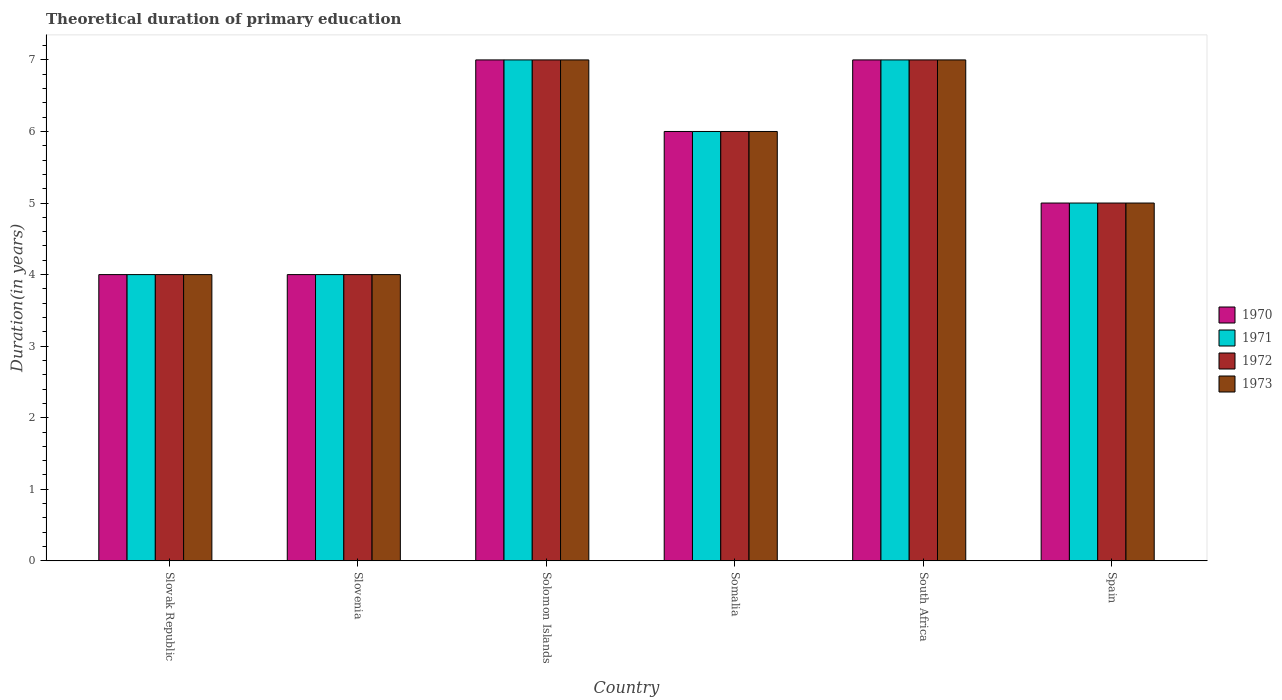Are the number of bars per tick equal to the number of legend labels?
Keep it short and to the point. Yes. Are the number of bars on each tick of the X-axis equal?
Provide a short and direct response. Yes. How many bars are there on the 2nd tick from the right?
Provide a succinct answer. 4. What is the label of the 6th group of bars from the left?
Offer a terse response. Spain. In how many cases, is the number of bars for a given country not equal to the number of legend labels?
Your answer should be very brief. 0. What is the total theoretical duration of primary education in 1971 in Slovenia?
Your answer should be compact. 4. Across all countries, what is the minimum total theoretical duration of primary education in 1973?
Make the answer very short. 4. In which country was the total theoretical duration of primary education in 1972 maximum?
Provide a succinct answer. Solomon Islands. In which country was the total theoretical duration of primary education in 1972 minimum?
Your answer should be very brief. Slovak Republic. What is the difference between the total theoretical duration of primary education in 1971 in Spain and the total theoretical duration of primary education in 1973 in Solomon Islands?
Ensure brevity in your answer.  -2. In how many countries, is the total theoretical duration of primary education in 1971 greater than 5.4 years?
Offer a terse response. 3. What is the ratio of the total theoretical duration of primary education in 1972 in Slovak Republic to that in South Africa?
Your response must be concise. 0.57. Is the total theoretical duration of primary education in 1972 in Somalia less than that in Spain?
Provide a short and direct response. No. What is the difference between the highest and the second highest total theoretical duration of primary education in 1973?
Provide a succinct answer. -1. What is the difference between the highest and the lowest total theoretical duration of primary education in 1971?
Offer a terse response. 3. Is the sum of the total theoretical duration of primary education in 1971 in Slovenia and Spain greater than the maximum total theoretical duration of primary education in 1973 across all countries?
Offer a terse response. Yes. What does the 2nd bar from the right in Slovenia represents?
Keep it short and to the point. 1972. How many bars are there?
Your response must be concise. 24. Are all the bars in the graph horizontal?
Provide a short and direct response. No. Are the values on the major ticks of Y-axis written in scientific E-notation?
Ensure brevity in your answer.  No. Does the graph contain any zero values?
Make the answer very short. No. Where does the legend appear in the graph?
Your response must be concise. Center right. How many legend labels are there?
Provide a succinct answer. 4. What is the title of the graph?
Keep it short and to the point. Theoretical duration of primary education. What is the label or title of the X-axis?
Your response must be concise. Country. What is the label or title of the Y-axis?
Keep it short and to the point. Duration(in years). What is the Duration(in years) in 1971 in Slovak Republic?
Make the answer very short. 4. What is the Duration(in years) of 1972 in Slovak Republic?
Make the answer very short. 4. What is the Duration(in years) of 1970 in Slovenia?
Offer a terse response. 4. What is the Duration(in years) of 1971 in Slovenia?
Provide a short and direct response. 4. What is the Duration(in years) in 1972 in Solomon Islands?
Your answer should be very brief. 7. What is the Duration(in years) in 1973 in Solomon Islands?
Give a very brief answer. 7. What is the Duration(in years) in 1971 in Somalia?
Provide a succinct answer. 6. What is the Duration(in years) of 1973 in Somalia?
Ensure brevity in your answer.  6. What is the Duration(in years) in 1971 in South Africa?
Give a very brief answer. 7. What is the Duration(in years) of 1972 in South Africa?
Offer a terse response. 7. What is the Duration(in years) of 1970 in Spain?
Ensure brevity in your answer.  5. What is the Duration(in years) of 1971 in Spain?
Ensure brevity in your answer.  5. Across all countries, what is the minimum Duration(in years) of 1970?
Offer a terse response. 4. Across all countries, what is the minimum Duration(in years) in 1971?
Give a very brief answer. 4. Across all countries, what is the minimum Duration(in years) of 1972?
Your answer should be compact. 4. Across all countries, what is the minimum Duration(in years) of 1973?
Your answer should be compact. 4. What is the total Duration(in years) in 1971 in the graph?
Provide a succinct answer. 33. What is the total Duration(in years) of 1972 in the graph?
Make the answer very short. 33. What is the total Duration(in years) of 1973 in the graph?
Give a very brief answer. 33. What is the difference between the Duration(in years) in 1970 in Slovak Republic and that in Slovenia?
Provide a short and direct response. 0. What is the difference between the Duration(in years) of 1971 in Slovak Republic and that in Slovenia?
Provide a succinct answer. 0. What is the difference between the Duration(in years) of 1973 in Slovak Republic and that in Slovenia?
Offer a very short reply. 0. What is the difference between the Duration(in years) of 1971 in Slovak Republic and that in Solomon Islands?
Ensure brevity in your answer.  -3. What is the difference between the Duration(in years) in 1971 in Slovak Republic and that in Somalia?
Keep it short and to the point. -2. What is the difference between the Duration(in years) in 1972 in Slovak Republic and that in Somalia?
Give a very brief answer. -2. What is the difference between the Duration(in years) of 1973 in Slovak Republic and that in Somalia?
Give a very brief answer. -2. What is the difference between the Duration(in years) of 1971 in Slovak Republic and that in Spain?
Give a very brief answer. -1. What is the difference between the Duration(in years) in 1972 in Slovak Republic and that in Spain?
Your answer should be very brief. -1. What is the difference between the Duration(in years) of 1973 in Slovak Republic and that in Spain?
Give a very brief answer. -1. What is the difference between the Duration(in years) in 1971 in Slovenia and that in Solomon Islands?
Provide a short and direct response. -3. What is the difference between the Duration(in years) of 1972 in Slovenia and that in Solomon Islands?
Your answer should be compact. -3. What is the difference between the Duration(in years) in 1973 in Slovenia and that in Solomon Islands?
Your response must be concise. -3. What is the difference between the Duration(in years) in 1973 in Slovenia and that in Somalia?
Provide a succinct answer. -2. What is the difference between the Duration(in years) of 1970 in Slovenia and that in South Africa?
Your answer should be compact. -3. What is the difference between the Duration(in years) in 1971 in Slovenia and that in South Africa?
Make the answer very short. -3. What is the difference between the Duration(in years) in 1972 in Slovenia and that in South Africa?
Ensure brevity in your answer.  -3. What is the difference between the Duration(in years) of 1973 in Slovenia and that in South Africa?
Offer a very short reply. -3. What is the difference between the Duration(in years) of 1973 in Slovenia and that in Spain?
Offer a terse response. -1. What is the difference between the Duration(in years) in 1970 in Solomon Islands and that in Somalia?
Your answer should be very brief. 1. What is the difference between the Duration(in years) in 1971 in Solomon Islands and that in Somalia?
Provide a succinct answer. 1. What is the difference between the Duration(in years) of 1973 in Solomon Islands and that in Somalia?
Give a very brief answer. 1. What is the difference between the Duration(in years) in 1972 in Solomon Islands and that in South Africa?
Your answer should be very brief. 0. What is the difference between the Duration(in years) in 1971 in Solomon Islands and that in Spain?
Your response must be concise. 2. What is the difference between the Duration(in years) of 1972 in Solomon Islands and that in Spain?
Give a very brief answer. 2. What is the difference between the Duration(in years) in 1972 in Somalia and that in South Africa?
Provide a succinct answer. -1. What is the difference between the Duration(in years) of 1970 in South Africa and that in Spain?
Keep it short and to the point. 2. What is the difference between the Duration(in years) of 1971 in South Africa and that in Spain?
Your response must be concise. 2. What is the difference between the Duration(in years) of 1973 in South Africa and that in Spain?
Your response must be concise. 2. What is the difference between the Duration(in years) of 1970 in Slovak Republic and the Duration(in years) of 1972 in Slovenia?
Make the answer very short. 0. What is the difference between the Duration(in years) of 1970 in Slovak Republic and the Duration(in years) of 1973 in Slovenia?
Provide a succinct answer. 0. What is the difference between the Duration(in years) in 1971 in Slovak Republic and the Duration(in years) in 1972 in Slovenia?
Give a very brief answer. 0. What is the difference between the Duration(in years) in 1972 in Slovak Republic and the Duration(in years) in 1973 in Slovenia?
Provide a succinct answer. 0. What is the difference between the Duration(in years) in 1971 in Slovak Republic and the Duration(in years) in 1972 in Solomon Islands?
Ensure brevity in your answer.  -3. What is the difference between the Duration(in years) of 1971 in Slovak Republic and the Duration(in years) of 1973 in Solomon Islands?
Offer a terse response. -3. What is the difference between the Duration(in years) of 1970 in Slovak Republic and the Duration(in years) of 1971 in Somalia?
Your response must be concise. -2. What is the difference between the Duration(in years) of 1971 in Slovak Republic and the Duration(in years) of 1972 in Somalia?
Your answer should be compact. -2. What is the difference between the Duration(in years) in 1970 in Slovak Republic and the Duration(in years) in 1971 in South Africa?
Your answer should be very brief. -3. What is the difference between the Duration(in years) of 1971 in Slovak Republic and the Duration(in years) of 1972 in South Africa?
Offer a very short reply. -3. What is the difference between the Duration(in years) in 1971 in Slovak Republic and the Duration(in years) in 1973 in South Africa?
Make the answer very short. -3. What is the difference between the Duration(in years) of 1970 in Slovak Republic and the Duration(in years) of 1971 in Spain?
Your response must be concise. -1. What is the difference between the Duration(in years) of 1972 in Slovak Republic and the Duration(in years) of 1973 in Spain?
Ensure brevity in your answer.  -1. What is the difference between the Duration(in years) of 1970 in Slovenia and the Duration(in years) of 1971 in Solomon Islands?
Your response must be concise. -3. What is the difference between the Duration(in years) of 1972 in Slovenia and the Duration(in years) of 1973 in Solomon Islands?
Keep it short and to the point. -3. What is the difference between the Duration(in years) in 1970 in Slovenia and the Duration(in years) in 1971 in Somalia?
Provide a short and direct response. -2. What is the difference between the Duration(in years) of 1970 in Slovenia and the Duration(in years) of 1972 in Somalia?
Your answer should be very brief. -2. What is the difference between the Duration(in years) of 1970 in Slovenia and the Duration(in years) of 1971 in South Africa?
Offer a very short reply. -3. What is the difference between the Duration(in years) in 1970 in Slovenia and the Duration(in years) in 1972 in South Africa?
Provide a short and direct response. -3. What is the difference between the Duration(in years) in 1972 in Slovenia and the Duration(in years) in 1973 in South Africa?
Ensure brevity in your answer.  -3. What is the difference between the Duration(in years) of 1970 in Slovenia and the Duration(in years) of 1971 in Spain?
Keep it short and to the point. -1. What is the difference between the Duration(in years) of 1970 in Slovenia and the Duration(in years) of 1973 in Spain?
Give a very brief answer. -1. What is the difference between the Duration(in years) of 1971 in Slovenia and the Duration(in years) of 1972 in Spain?
Provide a short and direct response. -1. What is the difference between the Duration(in years) of 1972 in Slovenia and the Duration(in years) of 1973 in Spain?
Your response must be concise. -1. What is the difference between the Duration(in years) in 1970 in Solomon Islands and the Duration(in years) in 1972 in Somalia?
Offer a terse response. 1. What is the difference between the Duration(in years) in 1970 in Solomon Islands and the Duration(in years) in 1973 in Somalia?
Your response must be concise. 1. What is the difference between the Duration(in years) of 1971 in Solomon Islands and the Duration(in years) of 1972 in Somalia?
Your answer should be compact. 1. What is the difference between the Duration(in years) of 1971 in Solomon Islands and the Duration(in years) of 1973 in Somalia?
Make the answer very short. 1. What is the difference between the Duration(in years) of 1970 in Solomon Islands and the Duration(in years) of 1971 in South Africa?
Your answer should be compact. 0. What is the difference between the Duration(in years) of 1970 in Solomon Islands and the Duration(in years) of 1972 in South Africa?
Make the answer very short. 0. What is the difference between the Duration(in years) in 1970 in Solomon Islands and the Duration(in years) in 1973 in South Africa?
Your answer should be very brief. 0. What is the difference between the Duration(in years) of 1971 in Solomon Islands and the Duration(in years) of 1973 in South Africa?
Give a very brief answer. 0. What is the difference between the Duration(in years) of 1970 in Solomon Islands and the Duration(in years) of 1971 in Spain?
Your response must be concise. 2. What is the difference between the Duration(in years) in 1970 in Solomon Islands and the Duration(in years) in 1973 in Spain?
Give a very brief answer. 2. What is the difference between the Duration(in years) of 1971 in Solomon Islands and the Duration(in years) of 1973 in Spain?
Offer a very short reply. 2. What is the difference between the Duration(in years) in 1972 in Solomon Islands and the Duration(in years) in 1973 in Spain?
Provide a short and direct response. 2. What is the difference between the Duration(in years) of 1970 in Somalia and the Duration(in years) of 1971 in South Africa?
Offer a terse response. -1. What is the difference between the Duration(in years) of 1970 in Somalia and the Duration(in years) of 1972 in South Africa?
Provide a short and direct response. -1. What is the difference between the Duration(in years) in 1971 in Somalia and the Duration(in years) in 1972 in South Africa?
Offer a terse response. -1. What is the difference between the Duration(in years) of 1971 in Somalia and the Duration(in years) of 1973 in South Africa?
Provide a succinct answer. -1. What is the difference between the Duration(in years) of 1972 in Somalia and the Duration(in years) of 1973 in South Africa?
Keep it short and to the point. -1. What is the difference between the Duration(in years) of 1970 in South Africa and the Duration(in years) of 1971 in Spain?
Your answer should be compact. 2. What is the difference between the Duration(in years) in 1970 in South Africa and the Duration(in years) in 1972 in Spain?
Your response must be concise. 2. What is the difference between the Duration(in years) of 1970 in South Africa and the Duration(in years) of 1973 in Spain?
Give a very brief answer. 2. What is the average Duration(in years) in 1972 per country?
Make the answer very short. 5.5. What is the difference between the Duration(in years) in 1970 and Duration(in years) in 1971 in Slovak Republic?
Your answer should be compact. 0. What is the difference between the Duration(in years) of 1970 and Duration(in years) of 1972 in Slovak Republic?
Make the answer very short. 0. What is the difference between the Duration(in years) in 1970 and Duration(in years) in 1973 in Slovak Republic?
Your answer should be very brief. 0. What is the difference between the Duration(in years) of 1971 and Duration(in years) of 1972 in Slovak Republic?
Offer a very short reply. 0. What is the difference between the Duration(in years) in 1971 and Duration(in years) in 1973 in Slovak Republic?
Provide a short and direct response. 0. What is the difference between the Duration(in years) in 1970 and Duration(in years) in 1973 in Slovenia?
Make the answer very short. 0. What is the difference between the Duration(in years) in 1971 and Duration(in years) in 1972 in Slovenia?
Provide a succinct answer. 0. What is the difference between the Duration(in years) in 1972 and Duration(in years) in 1973 in Slovenia?
Make the answer very short. 0. What is the difference between the Duration(in years) of 1970 and Duration(in years) of 1971 in Solomon Islands?
Your response must be concise. 0. What is the difference between the Duration(in years) of 1970 and Duration(in years) of 1972 in Solomon Islands?
Your response must be concise. 0. What is the difference between the Duration(in years) of 1970 and Duration(in years) of 1973 in Solomon Islands?
Provide a succinct answer. 0. What is the difference between the Duration(in years) of 1970 and Duration(in years) of 1973 in Somalia?
Give a very brief answer. 0. What is the difference between the Duration(in years) in 1971 and Duration(in years) in 1973 in Somalia?
Make the answer very short. 0. What is the difference between the Duration(in years) of 1972 and Duration(in years) of 1973 in Somalia?
Give a very brief answer. 0. What is the difference between the Duration(in years) of 1970 and Duration(in years) of 1972 in South Africa?
Provide a short and direct response. 0. What is the difference between the Duration(in years) in 1971 and Duration(in years) in 1973 in South Africa?
Your answer should be compact. 0. What is the difference between the Duration(in years) of 1972 and Duration(in years) of 1973 in South Africa?
Your answer should be very brief. 0. What is the difference between the Duration(in years) of 1970 and Duration(in years) of 1972 in Spain?
Provide a short and direct response. 0. What is the difference between the Duration(in years) of 1970 and Duration(in years) of 1973 in Spain?
Your answer should be compact. 0. What is the difference between the Duration(in years) in 1971 and Duration(in years) in 1973 in Spain?
Offer a terse response. 0. What is the ratio of the Duration(in years) of 1972 in Slovak Republic to that in Slovenia?
Keep it short and to the point. 1. What is the ratio of the Duration(in years) of 1973 in Slovak Republic to that in Slovenia?
Offer a very short reply. 1. What is the ratio of the Duration(in years) in 1971 in Slovak Republic to that in Solomon Islands?
Your answer should be very brief. 0.57. What is the ratio of the Duration(in years) in 1972 in Slovak Republic to that in Solomon Islands?
Keep it short and to the point. 0.57. What is the ratio of the Duration(in years) in 1970 in Slovak Republic to that in Somalia?
Your answer should be compact. 0.67. What is the ratio of the Duration(in years) of 1971 in Slovak Republic to that in Somalia?
Your answer should be compact. 0.67. What is the ratio of the Duration(in years) in 1972 in Slovak Republic to that in Somalia?
Provide a succinct answer. 0.67. What is the ratio of the Duration(in years) in 1972 in Slovak Republic to that in South Africa?
Offer a terse response. 0.57. What is the ratio of the Duration(in years) in 1973 in Slovak Republic to that in South Africa?
Your answer should be very brief. 0.57. What is the ratio of the Duration(in years) of 1971 in Slovak Republic to that in Spain?
Offer a terse response. 0.8. What is the ratio of the Duration(in years) in 1972 in Slovak Republic to that in Spain?
Ensure brevity in your answer.  0.8. What is the ratio of the Duration(in years) of 1970 in Slovenia to that in Solomon Islands?
Your answer should be very brief. 0.57. What is the ratio of the Duration(in years) in 1973 in Slovenia to that in Solomon Islands?
Offer a terse response. 0.57. What is the ratio of the Duration(in years) in 1970 in Slovenia to that in Somalia?
Give a very brief answer. 0.67. What is the ratio of the Duration(in years) in 1973 in Slovenia to that in Somalia?
Offer a terse response. 0.67. What is the ratio of the Duration(in years) of 1971 in Slovenia to that in South Africa?
Ensure brevity in your answer.  0.57. What is the ratio of the Duration(in years) of 1972 in Slovenia to that in South Africa?
Ensure brevity in your answer.  0.57. What is the ratio of the Duration(in years) in 1971 in Slovenia to that in Spain?
Provide a short and direct response. 0.8. What is the ratio of the Duration(in years) of 1972 in Slovenia to that in Spain?
Your answer should be compact. 0.8. What is the ratio of the Duration(in years) of 1973 in Slovenia to that in Spain?
Your answer should be compact. 0.8. What is the ratio of the Duration(in years) of 1972 in Solomon Islands to that in Somalia?
Provide a succinct answer. 1.17. What is the ratio of the Duration(in years) in 1973 in Solomon Islands to that in Somalia?
Give a very brief answer. 1.17. What is the ratio of the Duration(in years) of 1971 in Solomon Islands to that in South Africa?
Your answer should be very brief. 1. What is the ratio of the Duration(in years) of 1972 in Solomon Islands to that in South Africa?
Your answer should be very brief. 1. What is the ratio of the Duration(in years) of 1973 in Solomon Islands to that in South Africa?
Your response must be concise. 1. What is the ratio of the Duration(in years) in 1971 in Solomon Islands to that in Spain?
Your response must be concise. 1.4. What is the ratio of the Duration(in years) in 1973 in Solomon Islands to that in Spain?
Give a very brief answer. 1.4. What is the ratio of the Duration(in years) in 1971 in Somalia to that in South Africa?
Provide a short and direct response. 0.86. What is the ratio of the Duration(in years) of 1972 in Somalia to that in South Africa?
Make the answer very short. 0.86. What is the ratio of the Duration(in years) in 1973 in Somalia to that in South Africa?
Offer a terse response. 0.86. What is the ratio of the Duration(in years) in 1972 in Somalia to that in Spain?
Ensure brevity in your answer.  1.2. What is the ratio of the Duration(in years) in 1970 in South Africa to that in Spain?
Your answer should be very brief. 1.4. What is the ratio of the Duration(in years) of 1971 in South Africa to that in Spain?
Ensure brevity in your answer.  1.4. What is the ratio of the Duration(in years) in 1972 in South Africa to that in Spain?
Keep it short and to the point. 1.4. What is the ratio of the Duration(in years) in 1973 in South Africa to that in Spain?
Keep it short and to the point. 1.4. What is the difference between the highest and the second highest Duration(in years) in 1970?
Your answer should be very brief. 0. What is the difference between the highest and the second highest Duration(in years) of 1971?
Keep it short and to the point. 0. What is the difference between the highest and the second highest Duration(in years) of 1973?
Provide a succinct answer. 0. What is the difference between the highest and the lowest Duration(in years) of 1970?
Your answer should be compact. 3. What is the difference between the highest and the lowest Duration(in years) in 1973?
Ensure brevity in your answer.  3. 